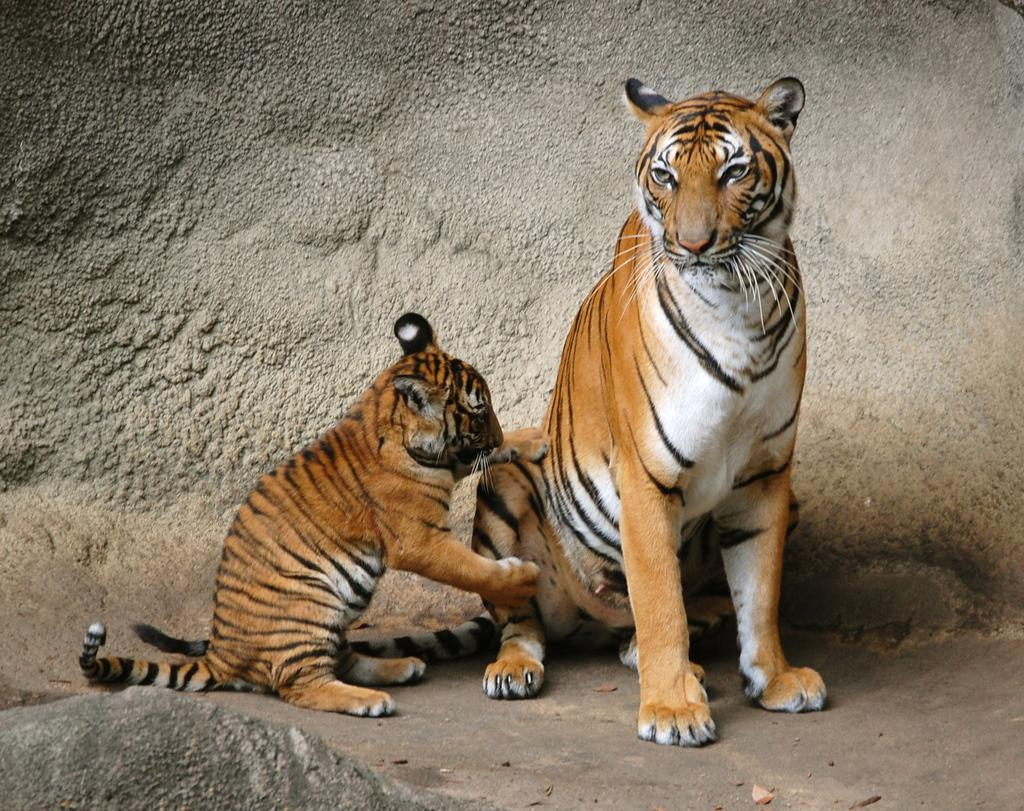What type of animal is the main subject of the image? There is a tiger in the image. Can you describe any other animals or figures in the image? Yes, there is a cub in the image. How many baby seats are visible in the image? There are no baby seats present in the image. What type of account is the tiger managing in the image? There is no account management depicted in the image; it features a tiger and a cub. 